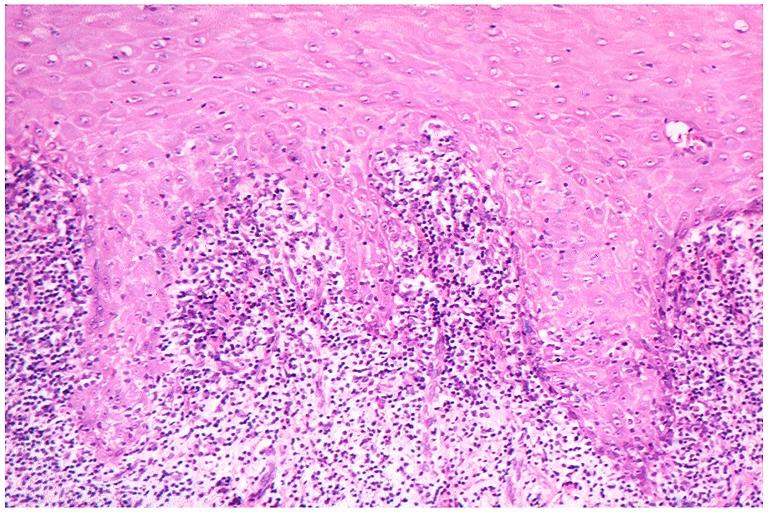does large gland show lichen planus?
Answer the question using a single word or phrase. No 